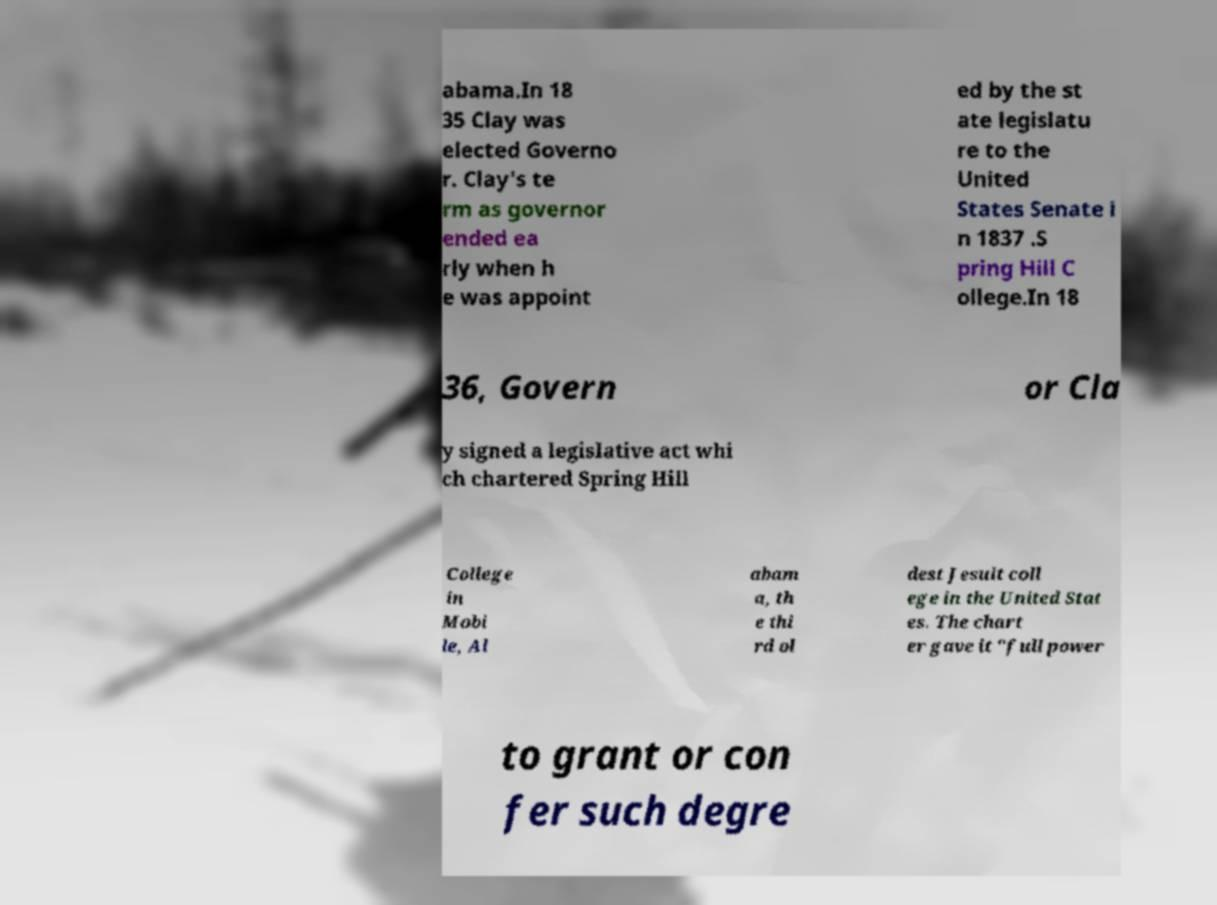I need the written content from this picture converted into text. Can you do that? abama.In 18 35 Clay was elected Governo r. Clay's te rm as governor ended ea rly when h e was appoint ed by the st ate legislatu re to the United States Senate i n 1837 .S pring Hill C ollege.In 18 36, Govern or Cla y signed a legislative act whi ch chartered Spring Hill College in Mobi le, Al abam a, th e thi rd ol dest Jesuit coll ege in the United Stat es. The chart er gave it "full power to grant or con fer such degre 